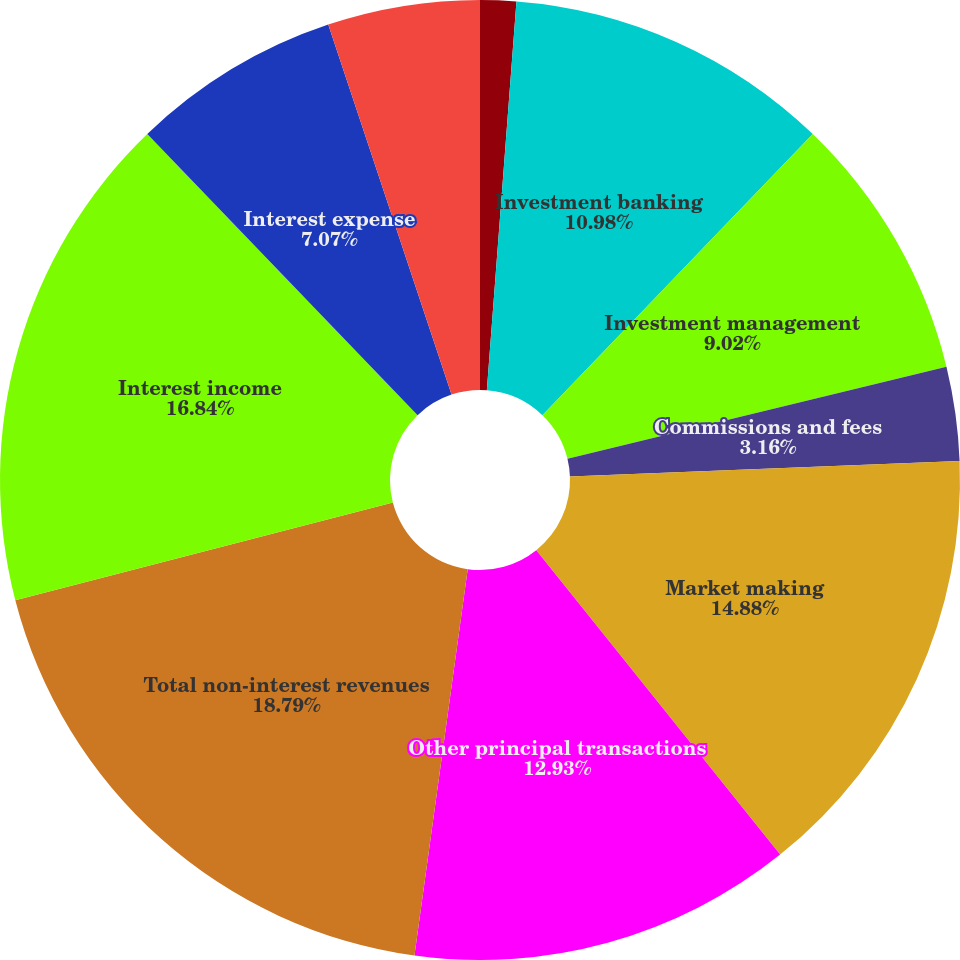Convert chart to OTSL. <chart><loc_0><loc_0><loc_500><loc_500><pie_chart><fcel>in millions<fcel>Investment banking<fcel>Investment management<fcel>Commissions and fees<fcel>Market making<fcel>Other principal transactions<fcel>Total non-interest revenues<fcel>Interest income<fcel>Interest expense<fcel>Net interest income<nl><fcel>1.21%<fcel>10.98%<fcel>9.02%<fcel>3.16%<fcel>14.88%<fcel>12.93%<fcel>18.79%<fcel>16.84%<fcel>7.07%<fcel>5.12%<nl></chart> 